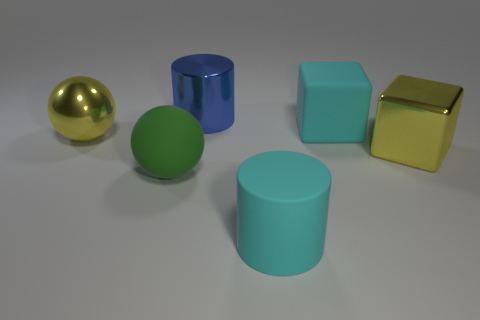How many big yellow metal cubes are on the left side of the big green ball?
Your answer should be very brief. 0. Are there any large balls made of the same material as the large green thing?
Keep it short and to the point. No. There is a yellow block that is the same size as the blue metal cylinder; what is it made of?
Provide a short and direct response. Metal. What is the size of the metallic object that is in front of the big rubber cube and to the left of the big rubber cylinder?
Offer a very short reply. Large. The large thing that is both in front of the matte cube and on the right side of the big cyan rubber cylinder is what color?
Ensure brevity in your answer.  Yellow. Are there fewer rubber cubes that are left of the big cyan matte block than blue metal cylinders left of the large yellow sphere?
Your answer should be compact. No. What number of big green matte objects are the same shape as the blue metal thing?
Give a very brief answer. 0. What is the size of the yellow object that is made of the same material as the large yellow cube?
Keep it short and to the point. Large. What is the color of the metallic thing that is behind the large cyan rubber object that is on the right side of the cyan rubber cylinder?
Make the answer very short. Blue. There is a blue shiny thing; is it the same shape as the yellow thing that is in front of the yellow ball?
Offer a very short reply. No. 